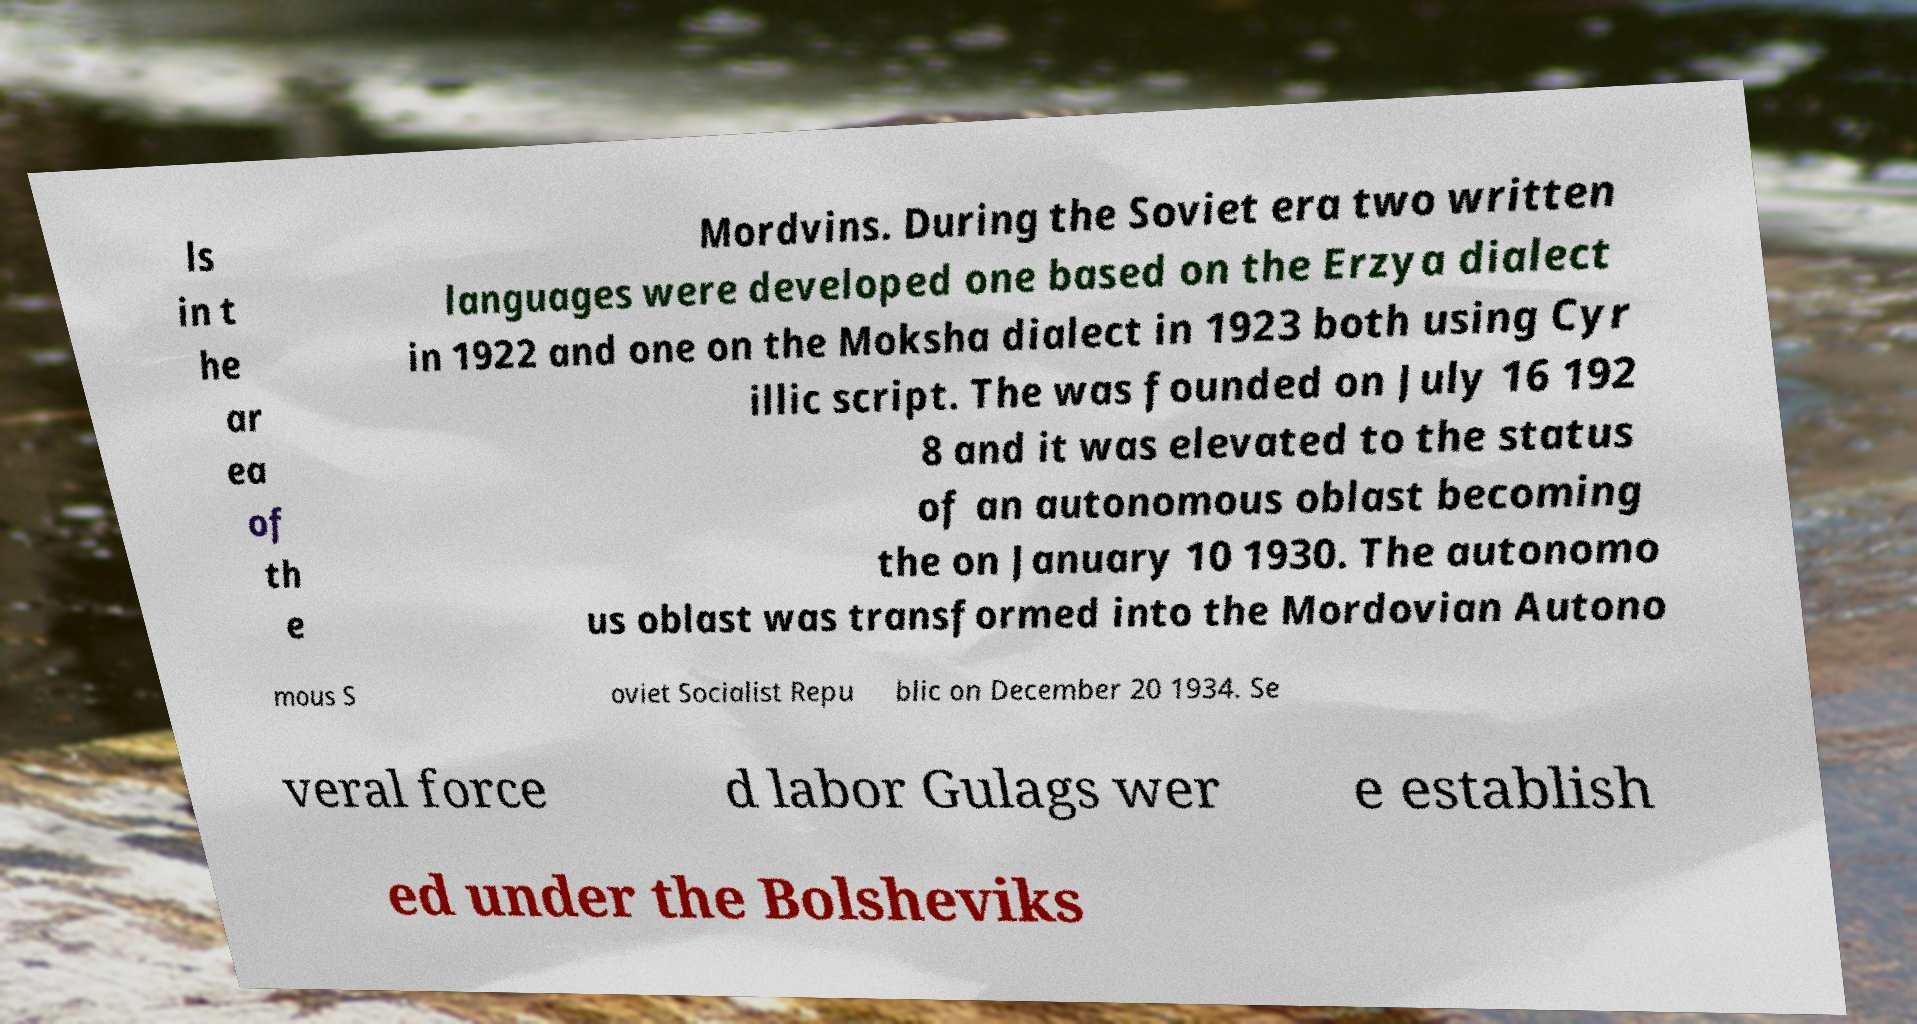What messages or text are displayed in this image? I need them in a readable, typed format. ls in t he ar ea of th e Mordvins. During the Soviet era two written languages were developed one based on the Erzya dialect in 1922 and one on the Moksha dialect in 1923 both using Cyr illic script. The was founded on July 16 192 8 and it was elevated to the status of an autonomous oblast becoming the on January 10 1930. The autonomo us oblast was transformed into the Mordovian Autono mous S oviet Socialist Repu blic on December 20 1934. Se veral force d labor Gulags wer e establish ed under the Bolsheviks 